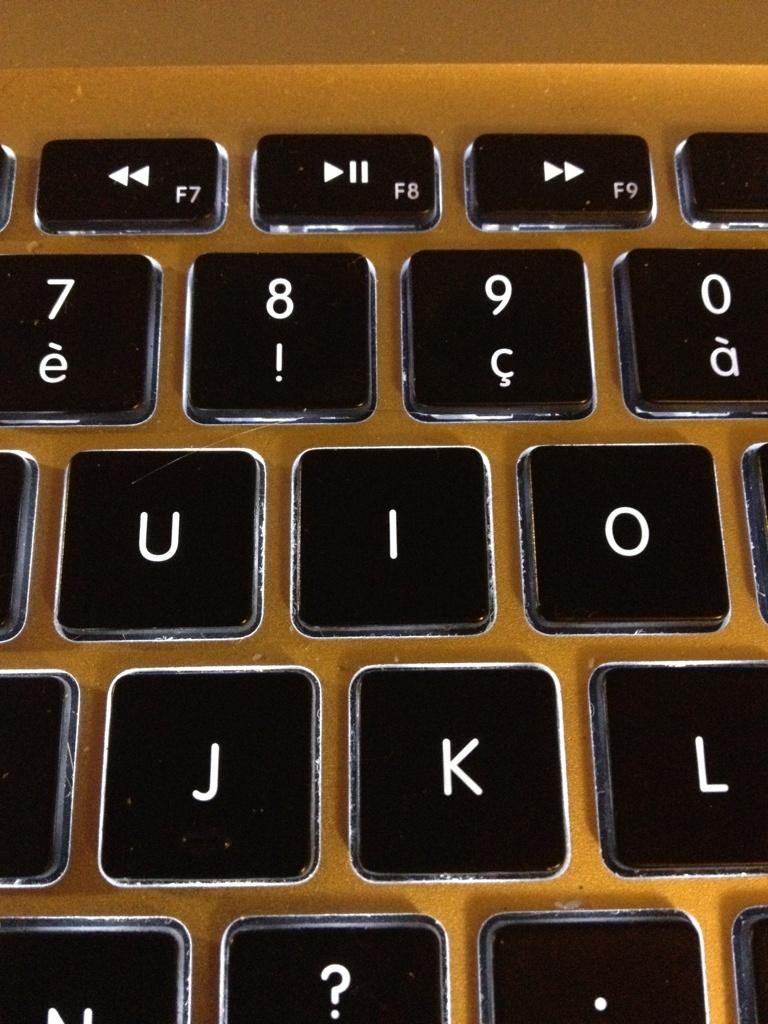<image>
Write a terse but informative summary of the picture. A close up of a computer where the letters U, I, O, J, K and L can be seen. 